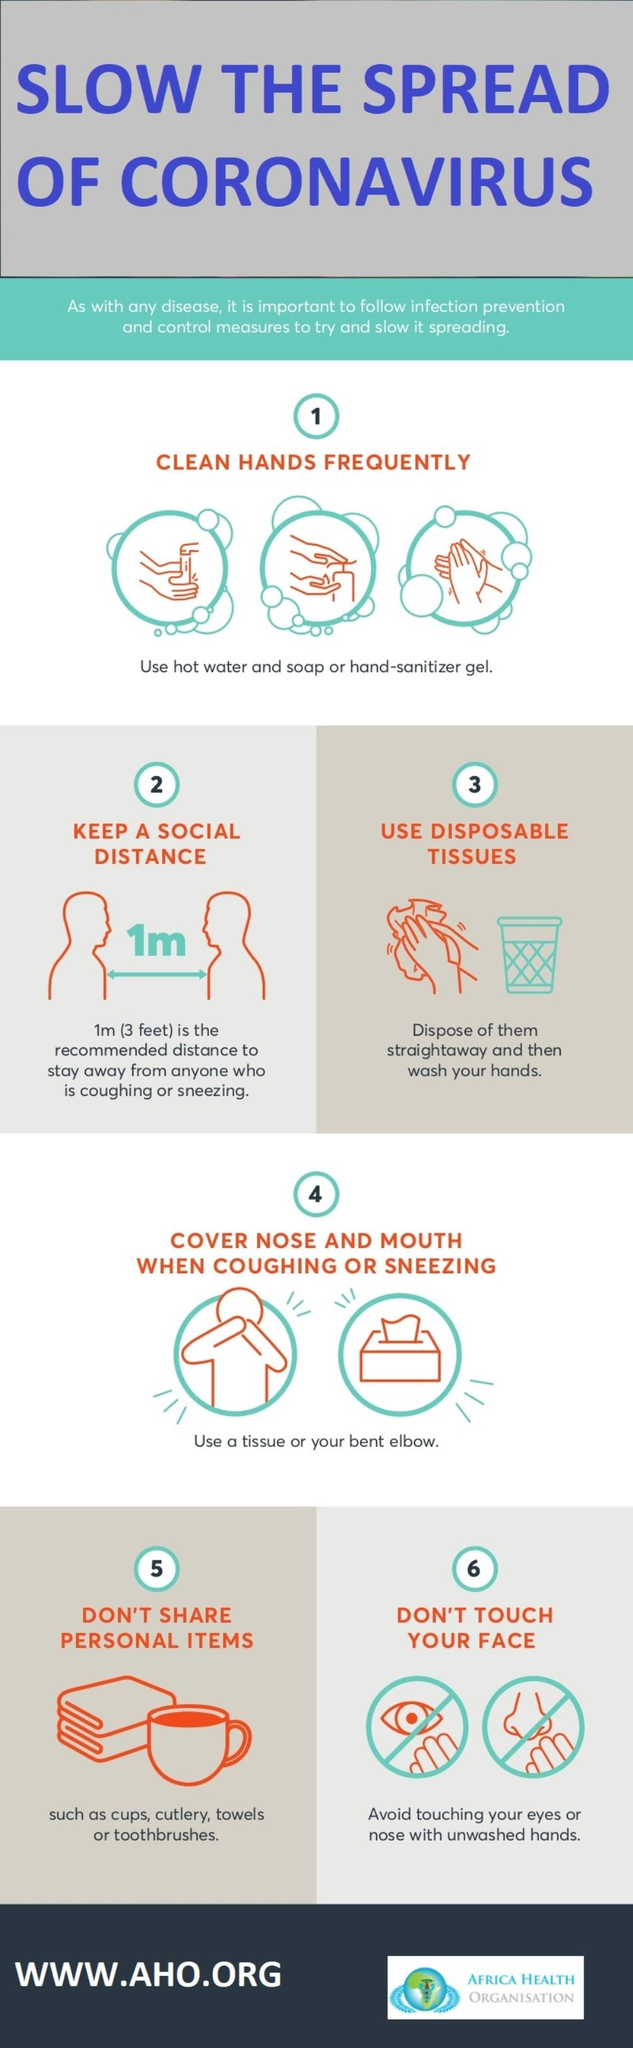Identify some key points in this picture. This infographic contains 4 personal items. The infographic depicts the facial features of a person, including the eyes and nose. 